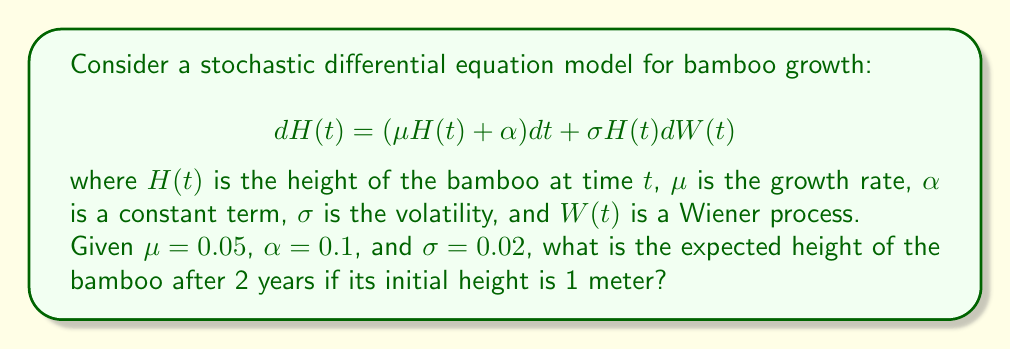Show me your answer to this math problem. To solve this problem, we need to follow these steps:

1) The general solution to this stochastic differential equation is:

   $$H(t) = H(0)e^{(\mu - \frac{\sigma^2}{2})t + \sigma W(t)} + \frac{\alpha}{\mu}(e^{(\mu - \frac{\sigma^2}{2})t + \sigma W(t)} - 1)$$

2) The expected value of $e^{\sigma W(t)}$ is $e^{\frac{\sigma^2 t}{2}}$, so the expected value of $H(t)$ is:

   $$E[H(t)] = H(0)e^{\mu t} + \frac{\alpha}{\mu}(e^{\mu t} - 1)$$

3) We are given:
   $H(0) = 1$ (initial height)
   $\mu = 0.05$
   $\alpha = 0.1$
   $t = 2$ (years)

4) Let's substitute these values:

   $$E[H(2)] = 1 \cdot e^{0.05 \cdot 2} + \frac{0.1}{0.05}(e^{0.05 \cdot 2} - 1)$$

5) Simplify:
   $$E[H(2)] = e^{0.1} + 2(e^{0.1} - 1)$$

6) Calculate:
   $$E[H(2)] \approx 1.105 + 2(1.105 - 1) \approx 1.315$$

Therefore, the expected height of the bamboo after 2 years is approximately 1.315 meters.
Answer: 1.315 meters 